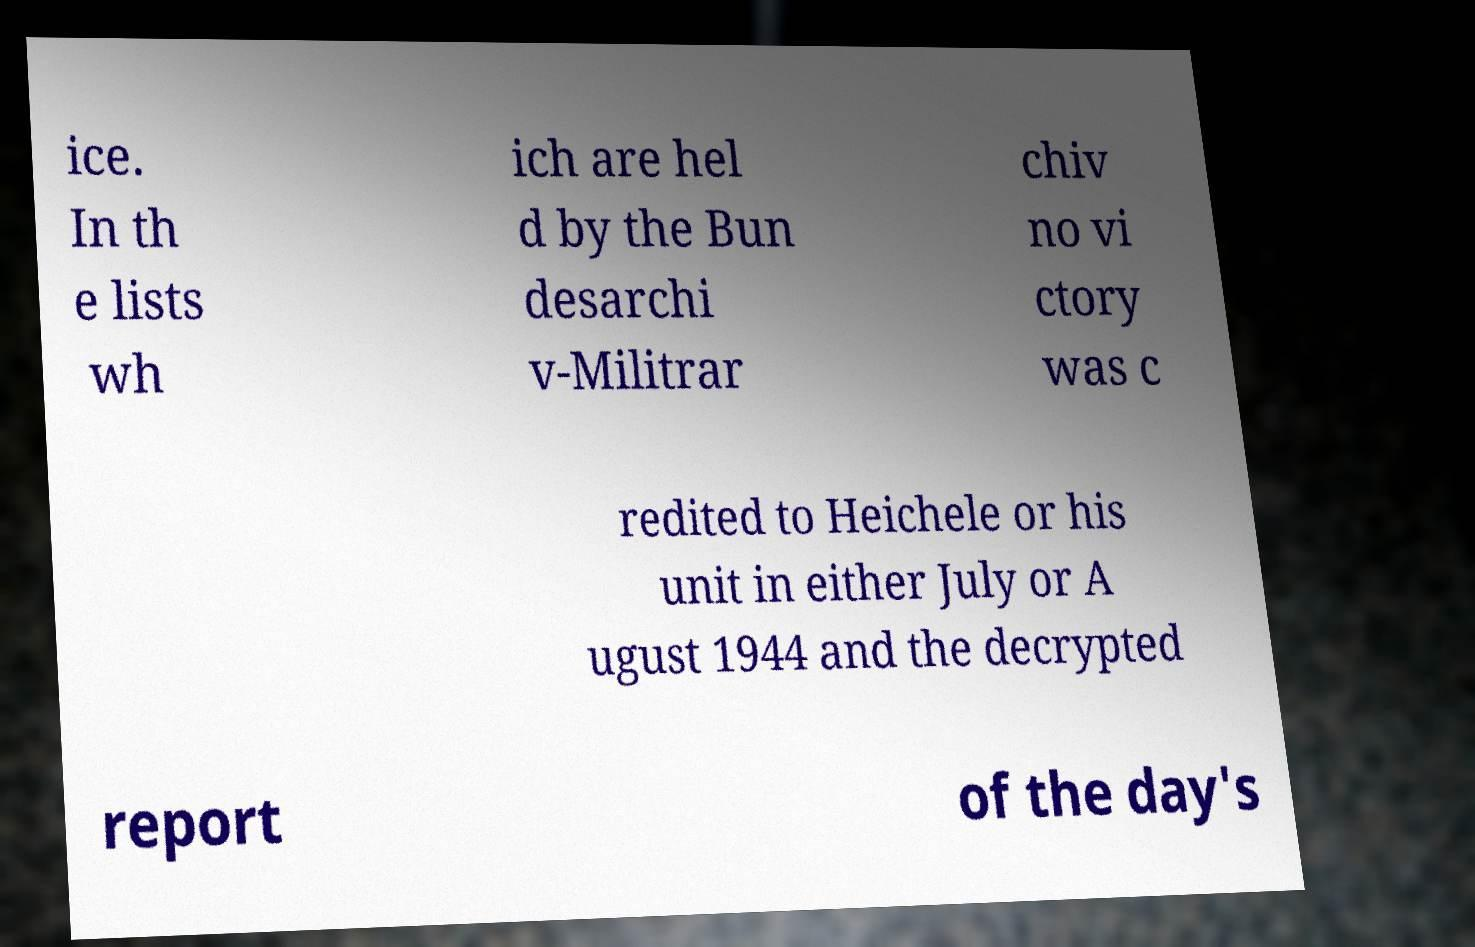Could you extract and type out the text from this image? ice. In th e lists wh ich are hel d by the Bun desarchi v-Militrar chiv no vi ctory was c redited to Heichele or his unit in either July or A ugust 1944 and the decrypted report of the day's 